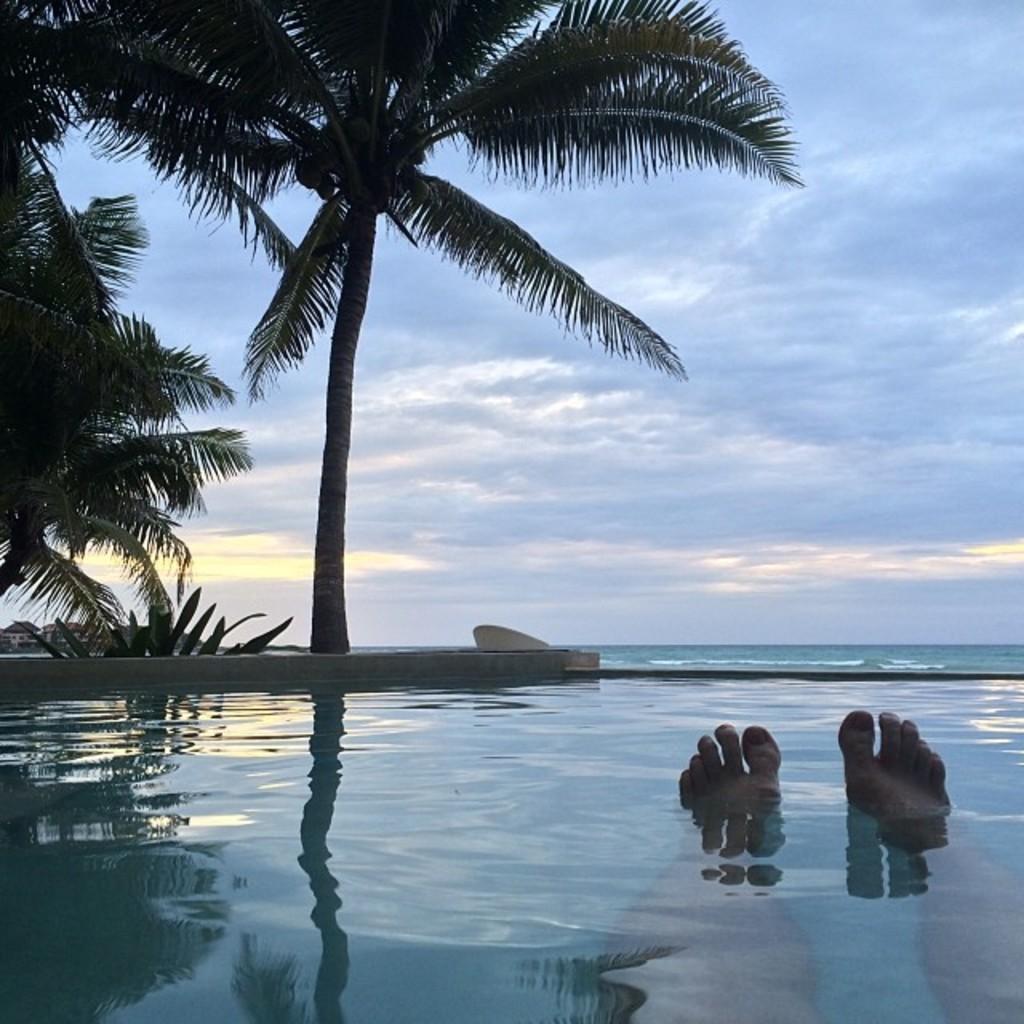Could you give a brief overview of what you see in this image? In this image we can see the legs of a person in the water, there are trees, buildings and in the background there is the sky. 